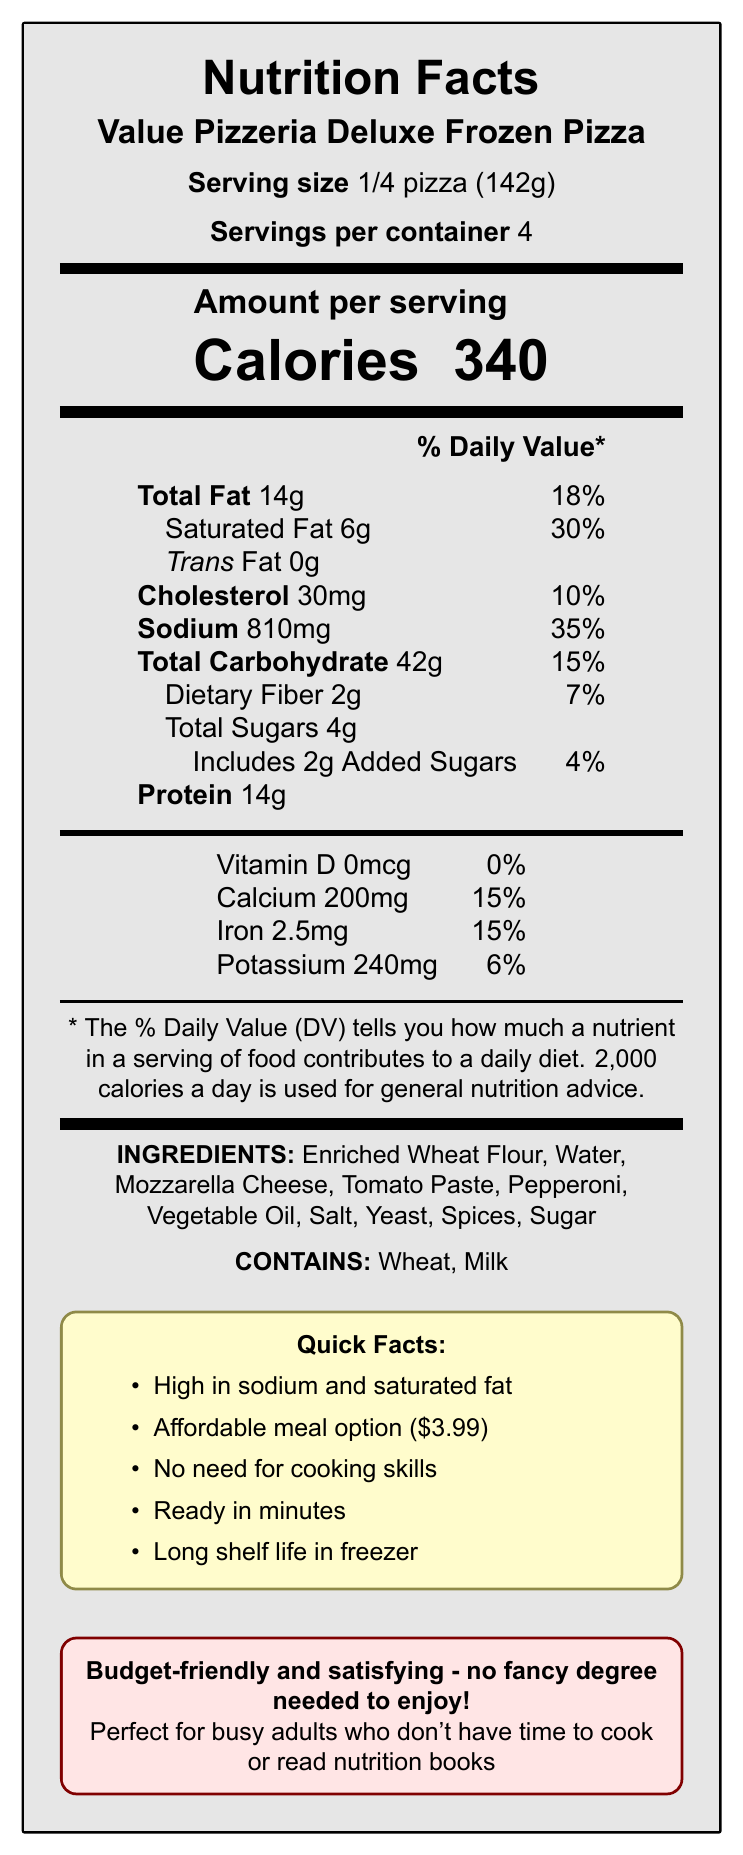what is the serving size? The serving size is clearly mentioned in the document as 1/4 pizza (142g).
Answer: 1/4 pizza (142g) how many calories are in one serving of the pizza? The calories per serving are listed as 340.
Answer: 340 what percentage of the daily value of sodium does one serving contain? The document states that each serving contains 810mg of sodium, which is 35% of the daily value.
Answer: 35% what are the top two ingredients listed? The top two ingredients listed in the ingredients section are Enriched Wheat Flour and Water.
Answer: Enriched Wheat Flour, Water how much protein is in one serving? The amount of protein per serving is stated as 14g.
Answer: 14g how much saturated fat does one serving contain? The document clearly mentions that one serving contains 6g of saturated fat.
Answer: 6g what is the price of the pizza? The price is listed as $3.99 in the quick facts section.
Answer: $3.99 what type of allergens are present in the pizza? The allergens section lists Wheat and Milk.
Answer: Wheat, Milk what is the product name? The product name is shown at the top as Value Pizzeria Deluxe Frozen Pizza.
Answer: Value Pizzeria Deluxe Frozen Pizza how much trans fat is in one serving? The trans fat amount is explicitly listed as 0g.
Answer: 0g how many servings are there per container? Each container has 4 servings as per the information provided.
Answer: 4 which nutrient has the highest daily value percentage per serving? A. Protein B. Saturated Fat C. Sodium Saturated fat has the highest daily value percentage per serving at 30%.
Answer: B. Saturated Fat what is the daily value percentage of calcium in one serving? A. 6% B. 10% C. 15% The daily value percentage for calcium is listed as 15%.
Answer: C. 15% is the pizza high in sodium? The quick facts section explicitly states that the pizza is high in sodium.
Answer: Yes describe the main idea of the document. The document lists detailed nutritional facts, ingredients, allergens, quick facts, and marketing information about the Value Pizzeria Deluxe Frozen Pizza.
Answer: The document provides nutritional information for the Value Pizzeria Deluxe Frozen Pizza, highlighting its key nutritional content, ingredients, allergens, price, and convenience features. It emphasizes that the pizza is high in sodium and saturated fat but is an affordable and convenient meal option. how much dietary fiber does the pizza contain per serving? The dietary fiber content per serving is listed as 2g.
Answer: 2g what is the percentage daily value of iron per serving? The iron percentage daily value per serving is 15%.
Answer: 15% what cooking skills are needed to prepare this pizza? The document states that no cooking skills are needed but does not detail any required skills.
Answer: Not enough information how long does this pizza need to be cooked? The document mentions that the pizza is ready in minutes but does not specify the exact cooking time.
Answer: Not enough information 